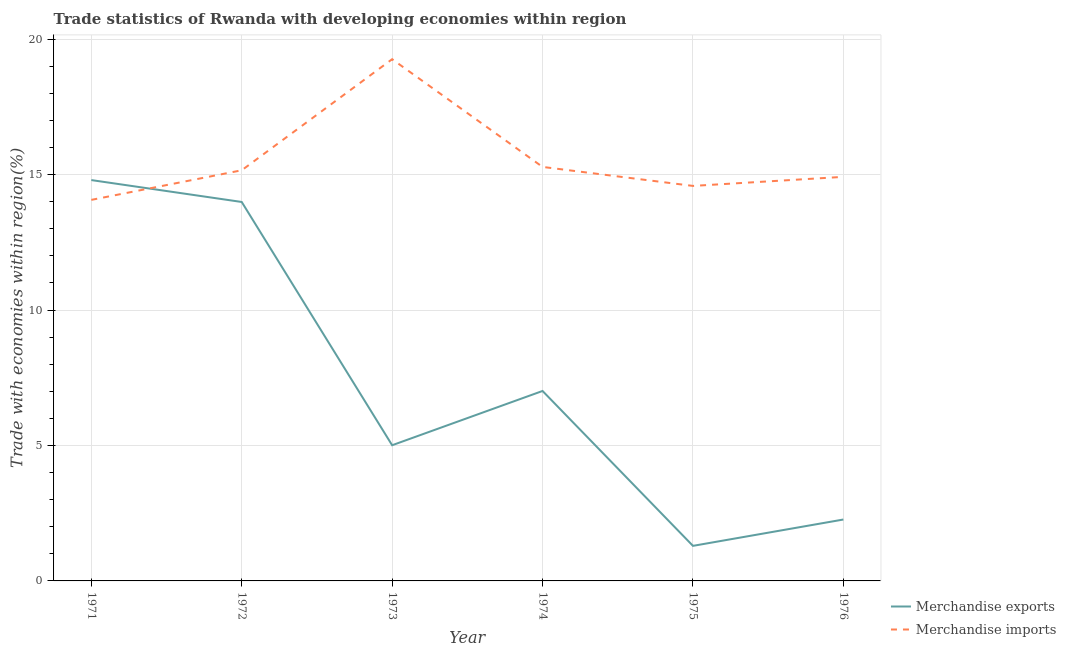Does the line corresponding to merchandise imports intersect with the line corresponding to merchandise exports?
Make the answer very short. Yes. Is the number of lines equal to the number of legend labels?
Your answer should be very brief. Yes. What is the merchandise exports in 1973?
Make the answer very short. 5.01. Across all years, what is the maximum merchandise exports?
Your response must be concise. 14.8. Across all years, what is the minimum merchandise exports?
Give a very brief answer. 1.29. In which year was the merchandise exports maximum?
Make the answer very short. 1971. In which year was the merchandise exports minimum?
Your response must be concise. 1975. What is the total merchandise imports in the graph?
Your response must be concise. 93.27. What is the difference between the merchandise imports in 1973 and that in 1974?
Make the answer very short. 3.98. What is the difference between the merchandise exports in 1972 and the merchandise imports in 1976?
Make the answer very short. -0.93. What is the average merchandise exports per year?
Give a very brief answer. 7.4. In the year 1974, what is the difference between the merchandise exports and merchandise imports?
Ensure brevity in your answer.  -8.27. What is the ratio of the merchandise exports in 1971 to that in 1974?
Make the answer very short. 2.11. Is the merchandise exports in 1972 less than that in 1973?
Give a very brief answer. No. Is the difference between the merchandise imports in 1973 and 1975 greater than the difference between the merchandise exports in 1973 and 1975?
Your response must be concise. Yes. What is the difference between the highest and the second highest merchandise exports?
Provide a short and direct response. 0.81. What is the difference between the highest and the lowest merchandise exports?
Provide a succinct answer. 13.5. Is the sum of the merchandise imports in 1972 and 1974 greater than the maximum merchandise exports across all years?
Ensure brevity in your answer.  Yes. Does the merchandise imports monotonically increase over the years?
Ensure brevity in your answer.  No. Is the merchandise exports strictly greater than the merchandise imports over the years?
Offer a terse response. No. What is the difference between two consecutive major ticks on the Y-axis?
Keep it short and to the point. 5. Are the values on the major ticks of Y-axis written in scientific E-notation?
Ensure brevity in your answer.  No. Does the graph contain grids?
Keep it short and to the point. Yes. Where does the legend appear in the graph?
Your answer should be very brief. Bottom right. How are the legend labels stacked?
Your response must be concise. Vertical. What is the title of the graph?
Keep it short and to the point. Trade statistics of Rwanda with developing economies within region. What is the label or title of the Y-axis?
Your response must be concise. Trade with economies within region(%). What is the Trade with economies within region(%) in Merchandise exports in 1971?
Keep it short and to the point. 14.8. What is the Trade with economies within region(%) in Merchandise imports in 1971?
Offer a terse response. 14.07. What is the Trade with economies within region(%) of Merchandise exports in 1972?
Ensure brevity in your answer.  13.99. What is the Trade with economies within region(%) of Merchandise imports in 1972?
Keep it short and to the point. 15.16. What is the Trade with economies within region(%) in Merchandise exports in 1973?
Ensure brevity in your answer.  5.01. What is the Trade with economies within region(%) of Merchandise imports in 1973?
Make the answer very short. 19.26. What is the Trade with economies within region(%) of Merchandise exports in 1974?
Ensure brevity in your answer.  7.01. What is the Trade with economies within region(%) in Merchandise imports in 1974?
Your response must be concise. 15.28. What is the Trade with economies within region(%) in Merchandise exports in 1975?
Your answer should be very brief. 1.29. What is the Trade with economies within region(%) in Merchandise imports in 1975?
Your answer should be compact. 14.58. What is the Trade with economies within region(%) of Merchandise exports in 1976?
Provide a succinct answer. 2.27. What is the Trade with economies within region(%) of Merchandise imports in 1976?
Give a very brief answer. 14.92. Across all years, what is the maximum Trade with economies within region(%) of Merchandise exports?
Your answer should be very brief. 14.8. Across all years, what is the maximum Trade with economies within region(%) of Merchandise imports?
Your answer should be very brief. 19.26. Across all years, what is the minimum Trade with economies within region(%) of Merchandise exports?
Give a very brief answer. 1.29. Across all years, what is the minimum Trade with economies within region(%) of Merchandise imports?
Give a very brief answer. 14.07. What is the total Trade with economies within region(%) of Merchandise exports in the graph?
Give a very brief answer. 44.37. What is the total Trade with economies within region(%) of Merchandise imports in the graph?
Offer a very short reply. 93.27. What is the difference between the Trade with economies within region(%) of Merchandise exports in 1971 and that in 1972?
Keep it short and to the point. 0.81. What is the difference between the Trade with economies within region(%) of Merchandise imports in 1971 and that in 1972?
Offer a terse response. -1.09. What is the difference between the Trade with economies within region(%) in Merchandise exports in 1971 and that in 1973?
Ensure brevity in your answer.  9.79. What is the difference between the Trade with economies within region(%) in Merchandise imports in 1971 and that in 1973?
Your response must be concise. -5.19. What is the difference between the Trade with economies within region(%) in Merchandise exports in 1971 and that in 1974?
Offer a very short reply. 7.79. What is the difference between the Trade with economies within region(%) in Merchandise imports in 1971 and that in 1974?
Your answer should be very brief. -1.22. What is the difference between the Trade with economies within region(%) of Merchandise exports in 1971 and that in 1975?
Provide a short and direct response. 13.5. What is the difference between the Trade with economies within region(%) in Merchandise imports in 1971 and that in 1975?
Keep it short and to the point. -0.52. What is the difference between the Trade with economies within region(%) of Merchandise exports in 1971 and that in 1976?
Offer a very short reply. 12.53. What is the difference between the Trade with economies within region(%) in Merchandise imports in 1971 and that in 1976?
Ensure brevity in your answer.  -0.85. What is the difference between the Trade with economies within region(%) of Merchandise exports in 1972 and that in 1973?
Offer a very short reply. 8.98. What is the difference between the Trade with economies within region(%) in Merchandise imports in 1972 and that in 1973?
Provide a short and direct response. -4.1. What is the difference between the Trade with economies within region(%) in Merchandise exports in 1972 and that in 1974?
Provide a succinct answer. 6.98. What is the difference between the Trade with economies within region(%) in Merchandise imports in 1972 and that in 1974?
Ensure brevity in your answer.  -0.12. What is the difference between the Trade with economies within region(%) of Merchandise exports in 1972 and that in 1975?
Your answer should be compact. 12.7. What is the difference between the Trade with economies within region(%) in Merchandise imports in 1972 and that in 1975?
Offer a very short reply. 0.58. What is the difference between the Trade with economies within region(%) in Merchandise exports in 1972 and that in 1976?
Your answer should be compact. 11.72. What is the difference between the Trade with economies within region(%) in Merchandise imports in 1972 and that in 1976?
Keep it short and to the point. 0.24. What is the difference between the Trade with economies within region(%) of Merchandise exports in 1973 and that in 1974?
Provide a succinct answer. -2. What is the difference between the Trade with economies within region(%) in Merchandise imports in 1973 and that in 1974?
Your answer should be compact. 3.98. What is the difference between the Trade with economies within region(%) in Merchandise exports in 1973 and that in 1975?
Make the answer very short. 3.71. What is the difference between the Trade with economies within region(%) in Merchandise imports in 1973 and that in 1975?
Offer a terse response. 4.68. What is the difference between the Trade with economies within region(%) in Merchandise exports in 1973 and that in 1976?
Ensure brevity in your answer.  2.74. What is the difference between the Trade with economies within region(%) in Merchandise imports in 1973 and that in 1976?
Offer a terse response. 4.34. What is the difference between the Trade with economies within region(%) in Merchandise exports in 1974 and that in 1975?
Give a very brief answer. 5.72. What is the difference between the Trade with economies within region(%) in Merchandise imports in 1974 and that in 1975?
Your answer should be very brief. 0.7. What is the difference between the Trade with economies within region(%) of Merchandise exports in 1974 and that in 1976?
Ensure brevity in your answer.  4.75. What is the difference between the Trade with economies within region(%) of Merchandise imports in 1974 and that in 1976?
Keep it short and to the point. 0.37. What is the difference between the Trade with economies within region(%) of Merchandise exports in 1975 and that in 1976?
Make the answer very short. -0.97. What is the difference between the Trade with economies within region(%) of Merchandise imports in 1975 and that in 1976?
Your response must be concise. -0.33. What is the difference between the Trade with economies within region(%) in Merchandise exports in 1971 and the Trade with economies within region(%) in Merchandise imports in 1972?
Your answer should be very brief. -0.36. What is the difference between the Trade with economies within region(%) in Merchandise exports in 1971 and the Trade with economies within region(%) in Merchandise imports in 1973?
Provide a short and direct response. -4.46. What is the difference between the Trade with economies within region(%) in Merchandise exports in 1971 and the Trade with economies within region(%) in Merchandise imports in 1974?
Your response must be concise. -0.49. What is the difference between the Trade with economies within region(%) of Merchandise exports in 1971 and the Trade with economies within region(%) of Merchandise imports in 1975?
Your answer should be very brief. 0.22. What is the difference between the Trade with economies within region(%) of Merchandise exports in 1971 and the Trade with economies within region(%) of Merchandise imports in 1976?
Provide a succinct answer. -0.12. What is the difference between the Trade with economies within region(%) in Merchandise exports in 1972 and the Trade with economies within region(%) in Merchandise imports in 1973?
Your answer should be compact. -5.27. What is the difference between the Trade with economies within region(%) in Merchandise exports in 1972 and the Trade with economies within region(%) in Merchandise imports in 1974?
Offer a very short reply. -1.29. What is the difference between the Trade with economies within region(%) in Merchandise exports in 1972 and the Trade with economies within region(%) in Merchandise imports in 1975?
Offer a very short reply. -0.59. What is the difference between the Trade with economies within region(%) of Merchandise exports in 1972 and the Trade with economies within region(%) of Merchandise imports in 1976?
Keep it short and to the point. -0.93. What is the difference between the Trade with economies within region(%) of Merchandise exports in 1973 and the Trade with economies within region(%) of Merchandise imports in 1974?
Provide a succinct answer. -10.27. What is the difference between the Trade with economies within region(%) in Merchandise exports in 1973 and the Trade with economies within region(%) in Merchandise imports in 1975?
Offer a terse response. -9.57. What is the difference between the Trade with economies within region(%) in Merchandise exports in 1973 and the Trade with economies within region(%) in Merchandise imports in 1976?
Offer a terse response. -9.91. What is the difference between the Trade with economies within region(%) of Merchandise exports in 1974 and the Trade with economies within region(%) of Merchandise imports in 1975?
Offer a terse response. -7.57. What is the difference between the Trade with economies within region(%) of Merchandise exports in 1974 and the Trade with economies within region(%) of Merchandise imports in 1976?
Make the answer very short. -7.9. What is the difference between the Trade with economies within region(%) in Merchandise exports in 1975 and the Trade with economies within region(%) in Merchandise imports in 1976?
Keep it short and to the point. -13.62. What is the average Trade with economies within region(%) in Merchandise exports per year?
Ensure brevity in your answer.  7.4. What is the average Trade with economies within region(%) in Merchandise imports per year?
Ensure brevity in your answer.  15.55. In the year 1971, what is the difference between the Trade with economies within region(%) in Merchandise exports and Trade with economies within region(%) in Merchandise imports?
Your answer should be compact. 0.73. In the year 1972, what is the difference between the Trade with economies within region(%) in Merchandise exports and Trade with economies within region(%) in Merchandise imports?
Make the answer very short. -1.17. In the year 1973, what is the difference between the Trade with economies within region(%) of Merchandise exports and Trade with economies within region(%) of Merchandise imports?
Offer a very short reply. -14.25. In the year 1974, what is the difference between the Trade with economies within region(%) of Merchandise exports and Trade with economies within region(%) of Merchandise imports?
Offer a very short reply. -8.27. In the year 1975, what is the difference between the Trade with economies within region(%) of Merchandise exports and Trade with economies within region(%) of Merchandise imports?
Ensure brevity in your answer.  -13.29. In the year 1976, what is the difference between the Trade with economies within region(%) in Merchandise exports and Trade with economies within region(%) in Merchandise imports?
Keep it short and to the point. -12.65. What is the ratio of the Trade with economies within region(%) of Merchandise exports in 1971 to that in 1972?
Your answer should be compact. 1.06. What is the ratio of the Trade with economies within region(%) of Merchandise imports in 1971 to that in 1972?
Your answer should be very brief. 0.93. What is the ratio of the Trade with economies within region(%) of Merchandise exports in 1971 to that in 1973?
Your response must be concise. 2.95. What is the ratio of the Trade with economies within region(%) in Merchandise imports in 1971 to that in 1973?
Provide a succinct answer. 0.73. What is the ratio of the Trade with economies within region(%) in Merchandise exports in 1971 to that in 1974?
Give a very brief answer. 2.11. What is the ratio of the Trade with economies within region(%) in Merchandise imports in 1971 to that in 1974?
Offer a terse response. 0.92. What is the ratio of the Trade with economies within region(%) in Merchandise exports in 1971 to that in 1975?
Keep it short and to the point. 11.43. What is the ratio of the Trade with economies within region(%) of Merchandise imports in 1971 to that in 1975?
Provide a short and direct response. 0.96. What is the ratio of the Trade with economies within region(%) of Merchandise exports in 1971 to that in 1976?
Provide a succinct answer. 6.53. What is the ratio of the Trade with economies within region(%) of Merchandise imports in 1971 to that in 1976?
Give a very brief answer. 0.94. What is the ratio of the Trade with economies within region(%) of Merchandise exports in 1972 to that in 1973?
Keep it short and to the point. 2.79. What is the ratio of the Trade with economies within region(%) in Merchandise imports in 1972 to that in 1973?
Provide a succinct answer. 0.79. What is the ratio of the Trade with economies within region(%) of Merchandise exports in 1972 to that in 1974?
Offer a very short reply. 1.99. What is the ratio of the Trade with economies within region(%) of Merchandise exports in 1972 to that in 1975?
Your response must be concise. 10.81. What is the ratio of the Trade with economies within region(%) in Merchandise imports in 1972 to that in 1975?
Give a very brief answer. 1.04. What is the ratio of the Trade with economies within region(%) of Merchandise exports in 1972 to that in 1976?
Provide a short and direct response. 6.17. What is the ratio of the Trade with economies within region(%) of Merchandise imports in 1972 to that in 1976?
Offer a terse response. 1.02. What is the ratio of the Trade with economies within region(%) in Merchandise exports in 1973 to that in 1974?
Make the answer very short. 0.71. What is the ratio of the Trade with economies within region(%) of Merchandise imports in 1973 to that in 1974?
Offer a terse response. 1.26. What is the ratio of the Trade with economies within region(%) of Merchandise exports in 1973 to that in 1975?
Your answer should be very brief. 3.87. What is the ratio of the Trade with economies within region(%) in Merchandise imports in 1973 to that in 1975?
Offer a very short reply. 1.32. What is the ratio of the Trade with economies within region(%) of Merchandise exports in 1973 to that in 1976?
Your response must be concise. 2.21. What is the ratio of the Trade with economies within region(%) of Merchandise imports in 1973 to that in 1976?
Make the answer very short. 1.29. What is the ratio of the Trade with economies within region(%) of Merchandise exports in 1974 to that in 1975?
Offer a very short reply. 5.42. What is the ratio of the Trade with economies within region(%) in Merchandise imports in 1974 to that in 1975?
Offer a terse response. 1.05. What is the ratio of the Trade with economies within region(%) in Merchandise exports in 1974 to that in 1976?
Make the answer very short. 3.09. What is the ratio of the Trade with economies within region(%) in Merchandise imports in 1974 to that in 1976?
Your answer should be compact. 1.02. What is the ratio of the Trade with economies within region(%) in Merchandise exports in 1975 to that in 1976?
Provide a short and direct response. 0.57. What is the ratio of the Trade with economies within region(%) in Merchandise imports in 1975 to that in 1976?
Keep it short and to the point. 0.98. What is the difference between the highest and the second highest Trade with economies within region(%) in Merchandise exports?
Provide a short and direct response. 0.81. What is the difference between the highest and the second highest Trade with economies within region(%) of Merchandise imports?
Give a very brief answer. 3.98. What is the difference between the highest and the lowest Trade with economies within region(%) in Merchandise exports?
Your answer should be very brief. 13.5. What is the difference between the highest and the lowest Trade with economies within region(%) of Merchandise imports?
Your answer should be very brief. 5.19. 